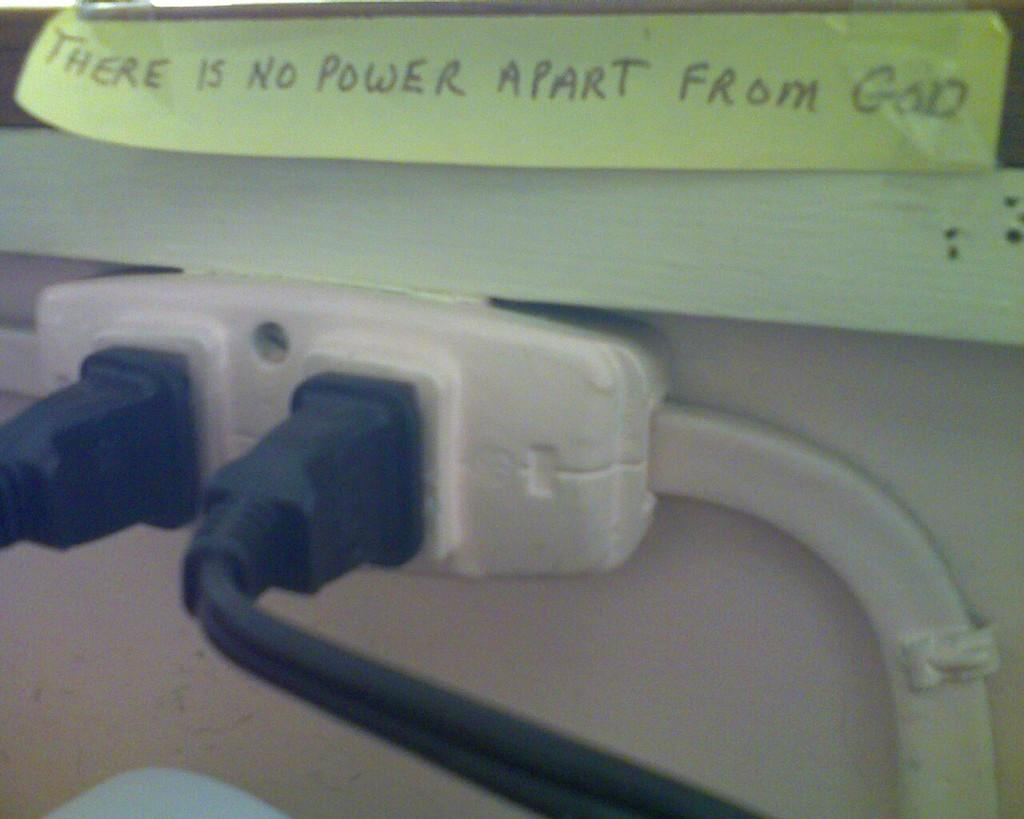What is attached to the board in the image? There is a paper attached to a board in the image. What electrical component can be seen in the image? There is a socket in the image. How many cables are connected to the socket? Two cables are attached to the socket. What type of cushion is being used in the battle depicted in the image? There is no battle or cushion present in the image; it features a paper attached to a board and a socket with two cables. What tax rate is applied to the electrical devices in the image? There is no information about tax rates in the image; it only shows a paper, a board, a socket, and two cables. 